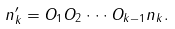Convert formula to latex. <formula><loc_0><loc_0><loc_500><loc_500>n _ { k } ^ { \prime } = O _ { 1 } O _ { 2 } \cdot \cdot \cdot O _ { k - 1 } n _ { k } .</formula> 